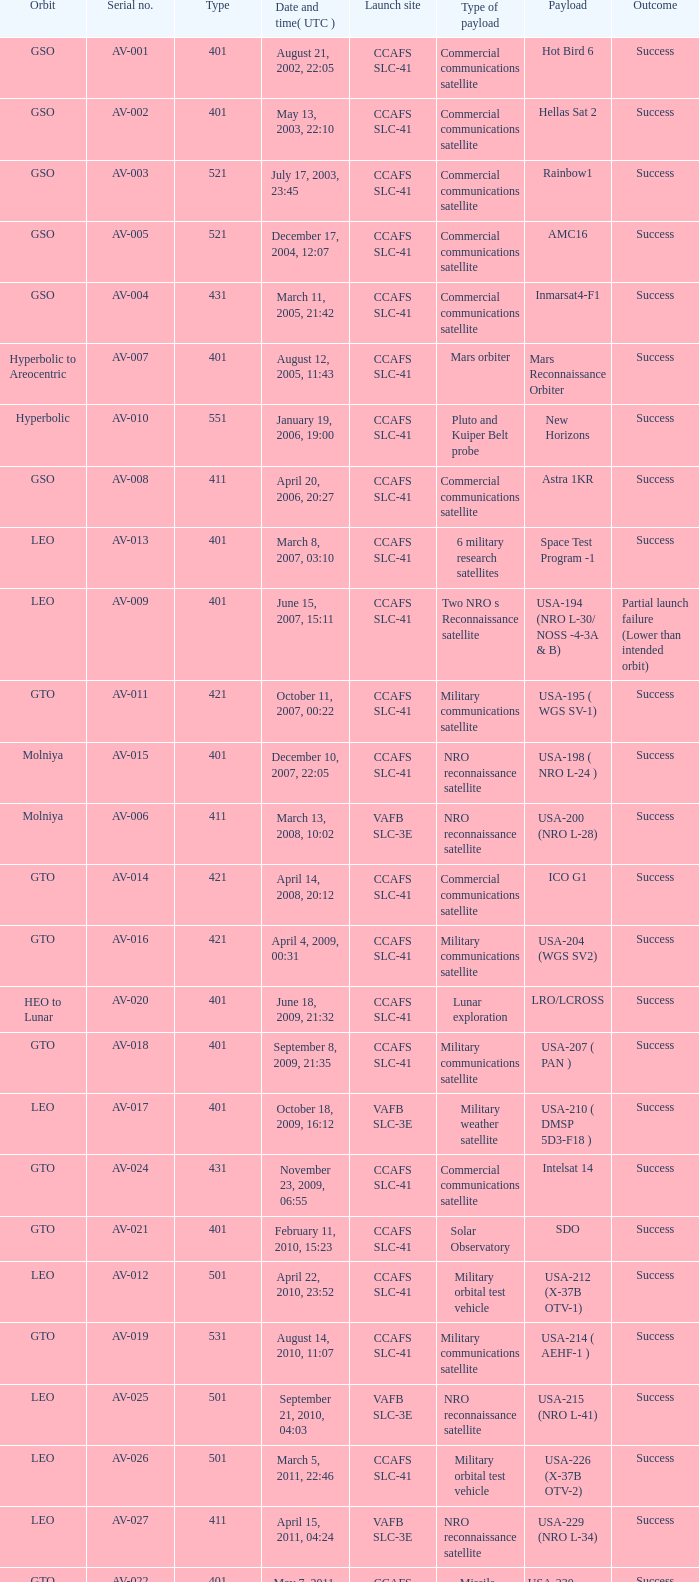For the payload of Van Allen Belts Exploration what's the serial number? AV-032. 